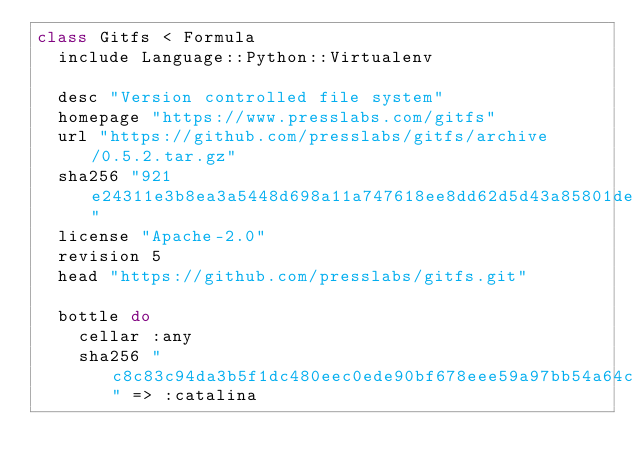<code> <loc_0><loc_0><loc_500><loc_500><_Ruby_>class Gitfs < Formula
  include Language::Python::Virtualenv

  desc "Version controlled file system"
  homepage "https://www.presslabs.com/gitfs"
  url "https://github.com/presslabs/gitfs/archive/0.5.2.tar.gz"
  sha256 "921e24311e3b8ea3a5448d698a11a747618ee8dd62d5d43a85801de0b111cbf3"
  license "Apache-2.0"
  revision 5
  head "https://github.com/presslabs/gitfs.git"

  bottle do
    cellar :any
    sha256 "c8c83c94da3b5f1dc480eec0ede90bf678eee59a97bb54a64cf94555d9c57752" => :catalina</code> 